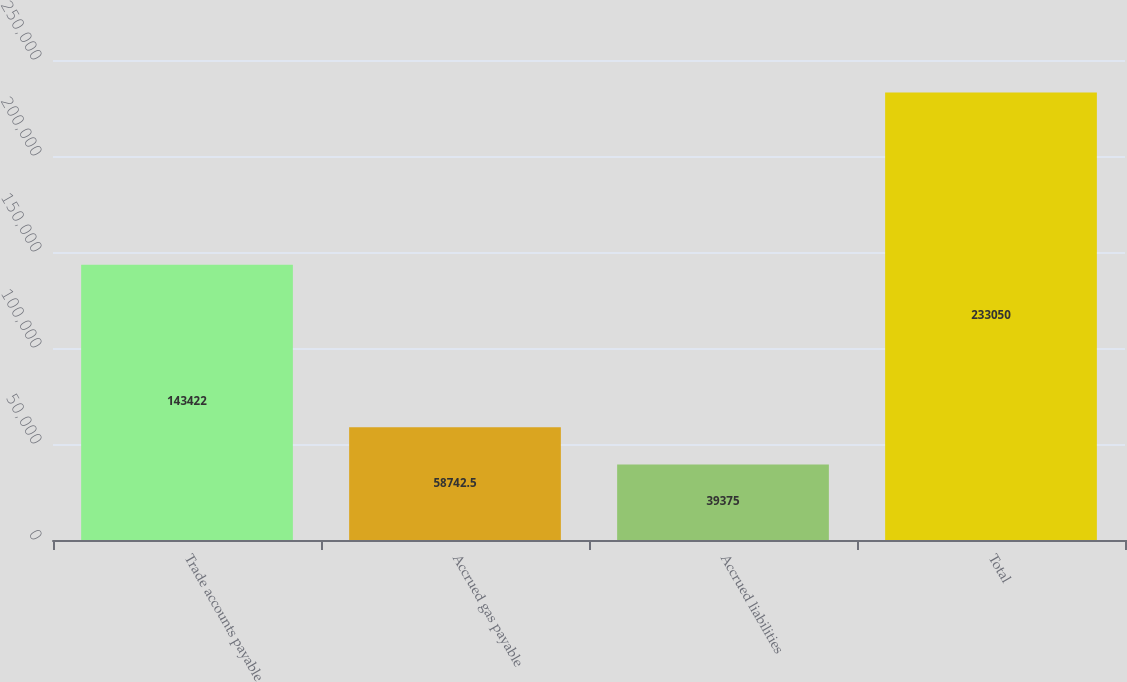Convert chart. <chart><loc_0><loc_0><loc_500><loc_500><bar_chart><fcel>Trade accounts payable<fcel>Accrued gas payable<fcel>Accrued liabilities<fcel>Total<nl><fcel>143422<fcel>58742.5<fcel>39375<fcel>233050<nl></chart> 